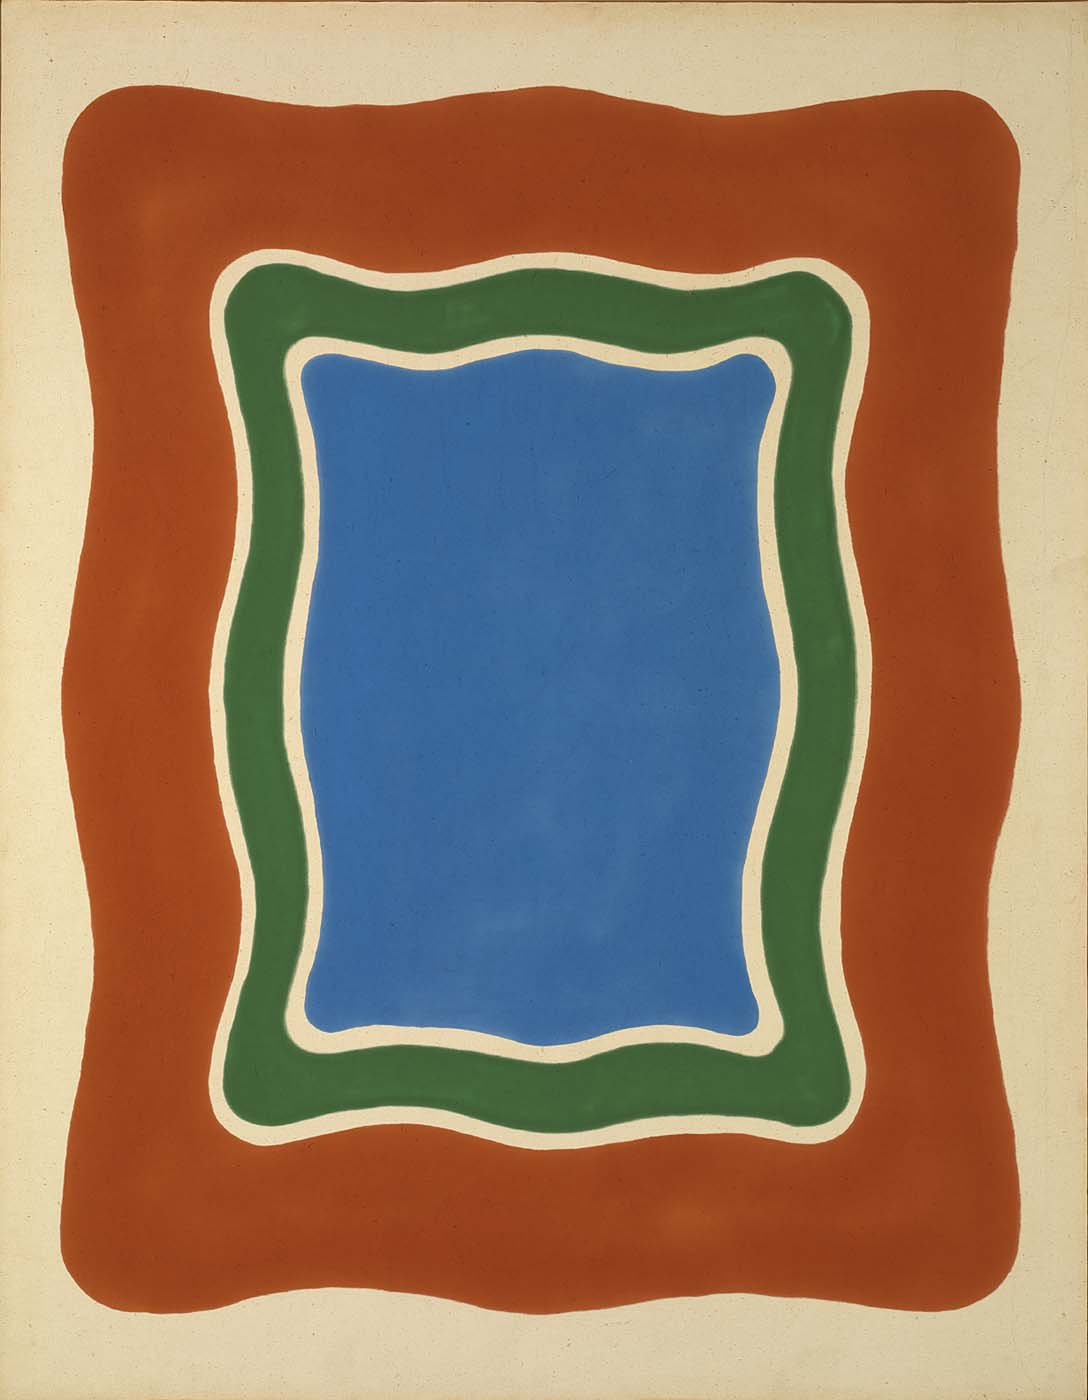Imagine this image as a living organism. Can you describe it in that context? Visualize the blue rectangle as the core or heart of a living organism, pulsating with calm energy. The green border acts as the circulatory system, channeling vitality and nutrients from the vibrant red exterior, which is the protective and nourishing outer layer. The curves and flows mimic natural processes, suggesting a rhythmic, living entity that thrives on the balance and interaction of its internal and external elements. 